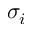Convert formula to latex. <formula><loc_0><loc_0><loc_500><loc_500>\sigma _ { i }</formula> 